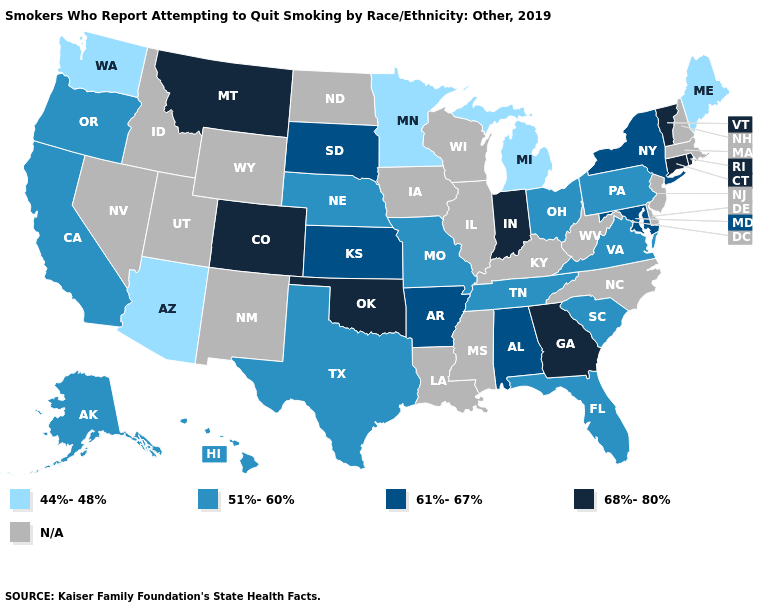Name the states that have a value in the range N/A?
Quick response, please. Delaware, Idaho, Illinois, Iowa, Kentucky, Louisiana, Massachusetts, Mississippi, Nevada, New Hampshire, New Jersey, New Mexico, North Carolina, North Dakota, Utah, West Virginia, Wisconsin, Wyoming. Name the states that have a value in the range 61%-67%?
Give a very brief answer. Alabama, Arkansas, Kansas, Maryland, New York, South Dakota. What is the value of Tennessee?
Be succinct. 51%-60%. Name the states that have a value in the range 68%-80%?
Answer briefly. Colorado, Connecticut, Georgia, Indiana, Montana, Oklahoma, Rhode Island, Vermont. Does the map have missing data?
Concise answer only. Yes. Name the states that have a value in the range 61%-67%?
Answer briefly. Alabama, Arkansas, Kansas, Maryland, New York, South Dakota. Name the states that have a value in the range 68%-80%?
Write a very short answer. Colorado, Connecticut, Georgia, Indiana, Montana, Oklahoma, Rhode Island, Vermont. Does Connecticut have the highest value in the Northeast?
Concise answer only. Yes. Does Montana have the lowest value in the USA?
Give a very brief answer. No. Among the states that border Arkansas , which have the lowest value?
Answer briefly. Missouri, Tennessee, Texas. What is the value of South Dakota?
Answer briefly. 61%-67%. Is the legend a continuous bar?
Quick response, please. No. What is the value of North Dakota?
Quick response, please. N/A. Among the states that border Illinois , which have the lowest value?
Give a very brief answer. Missouri. What is the value of Massachusetts?
Give a very brief answer. N/A. 